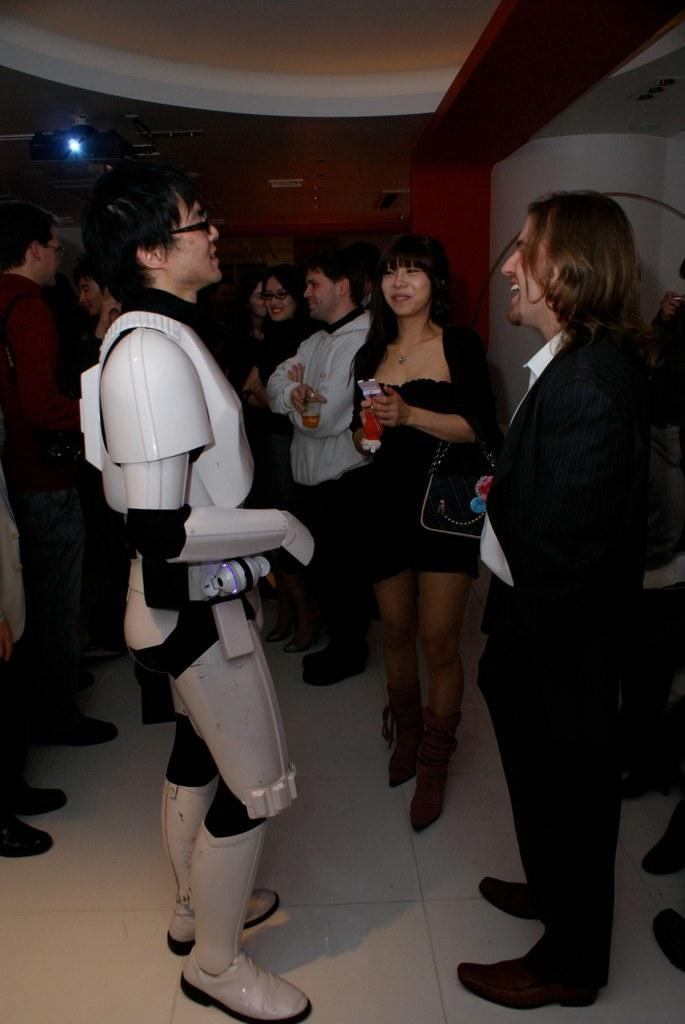How many people are in the image? There is a group of people in the image. What is the facial expression of the people in the image? The people are smiling. Can you describe any additional elements in the image? There is a focusing light visible in the image. What type of thread is being used by the people in the image? There is no thread present in the image; the people are simply smiling and there are no visible objects that would require thread. 